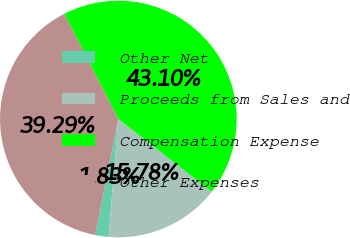Convert chart to OTSL. <chart><loc_0><loc_0><loc_500><loc_500><pie_chart><fcel>Other Net<fcel>Proceeds from Sales and<fcel>Compensation Expense<fcel>Other Expenses<nl><fcel>1.83%<fcel>15.78%<fcel>43.1%<fcel>39.29%<nl></chart> 